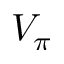Convert formula to latex. <formula><loc_0><loc_0><loc_500><loc_500>V _ { \pi }</formula> 